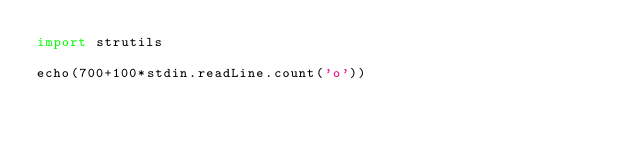Convert code to text. <code><loc_0><loc_0><loc_500><loc_500><_Nim_>import strutils

echo(700+100*stdin.readLine.count('o'))
</code> 